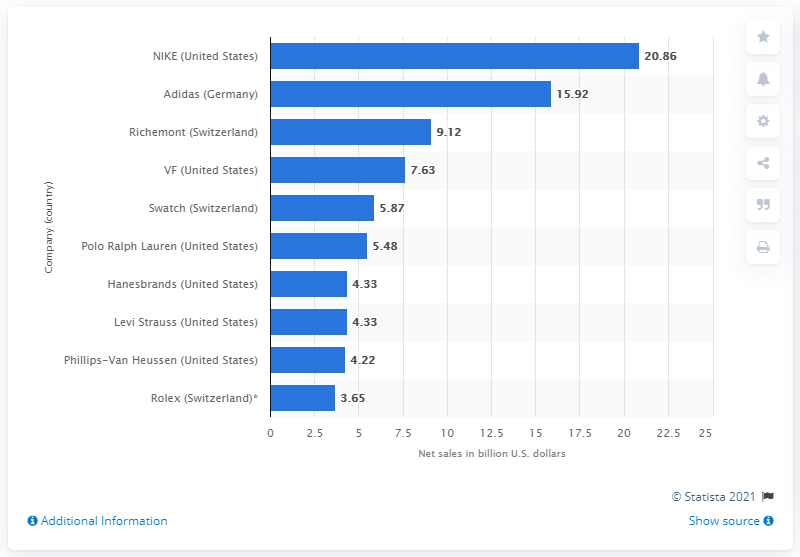Outline some significant characteristics in this image. In 2010, NIKE reported net sales of 20.86 billion U.S. dollars. 